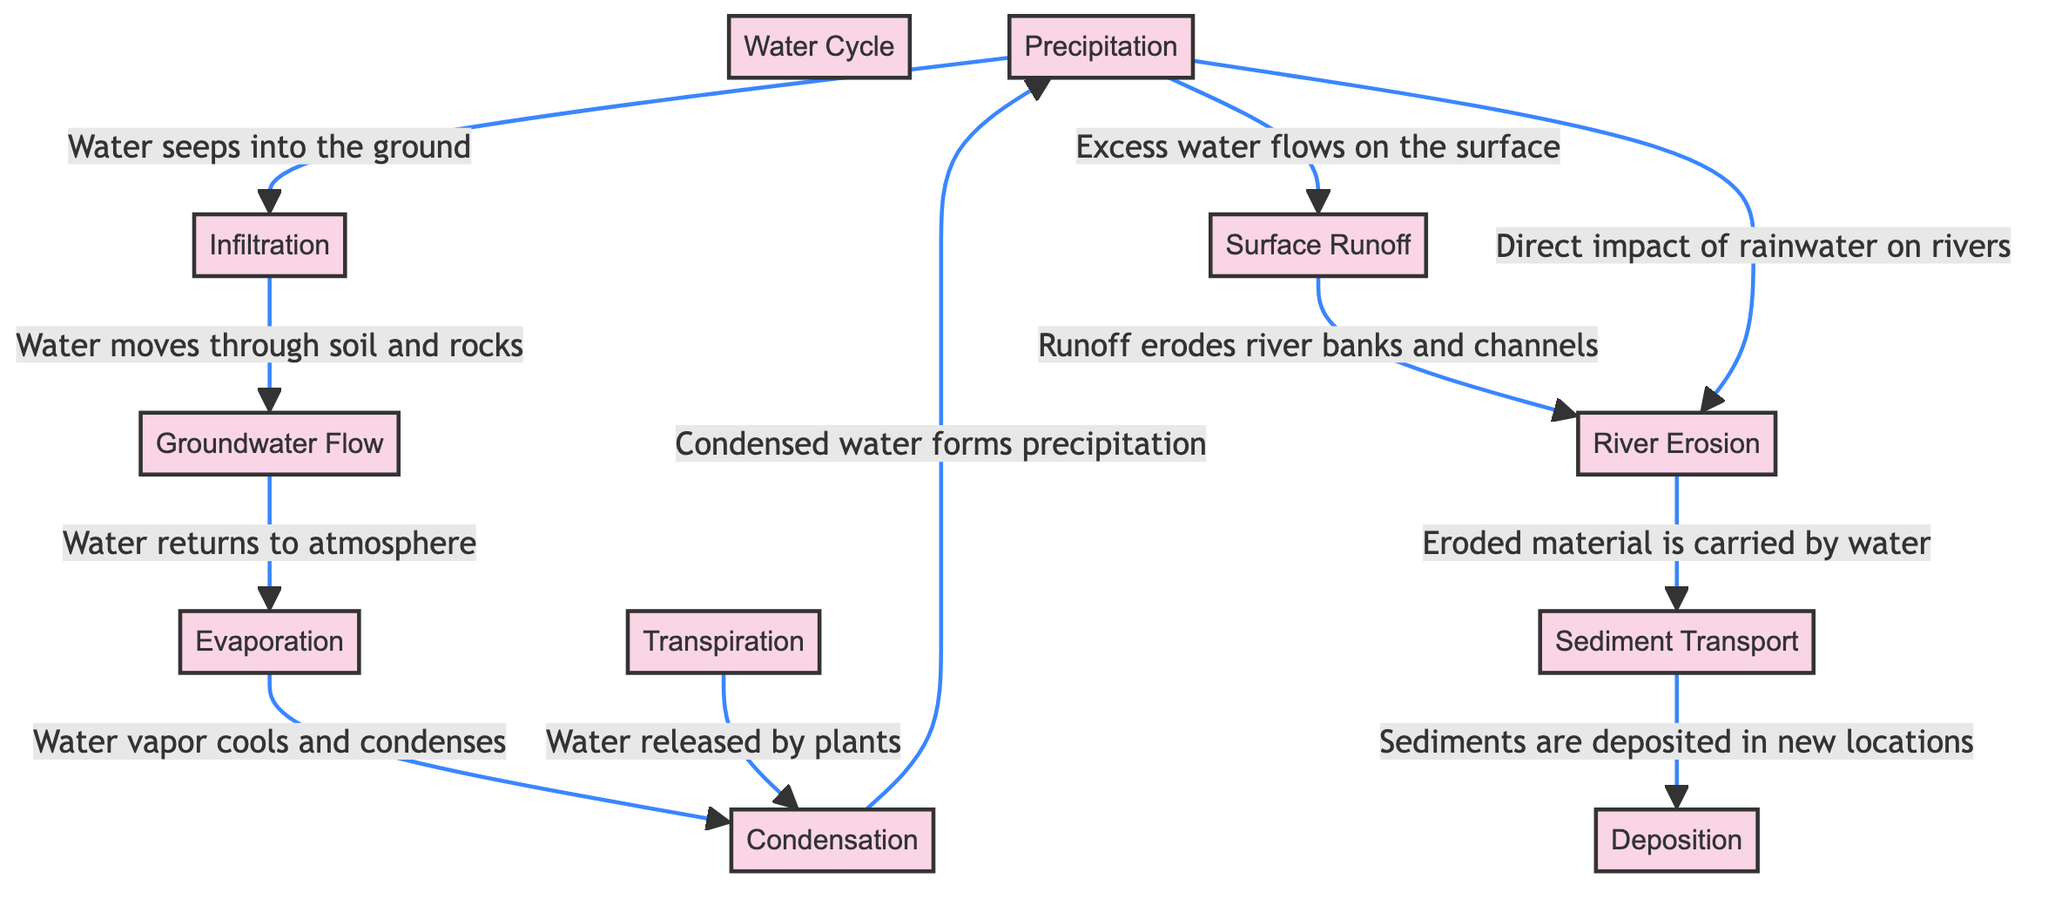What is the starting point of the diagram? The diagram begins with the node labeled "Water Cycle," which serves as the primary process connecting all other elements.
Answer: Water Cycle How many processes are shown in the diagram? There are 11 nodes labeled as processes, which include all the steps of the water cycle and its effects on geological structures.
Answer: 11 What process follows "Condensation"? The process that follows "Condensation" is "Precipitation," indicating that condensation leads to the formation of precipitation.
Answer: Precipitation Which process is directly impacted by "Precipitation"? "River Erosion" is directly impacted by "Precipitation," as indicated by a connection showing the direct influence of rainwater on rivers.
Answer: River Erosion What is the relationship between "Surface Runoff" and "River Erosion"? "Surface Runoff" leads to "River Erosion," as the runoff erodes river banks and channels.
Answer: Runoff erodes river banks and channels What happens to the eroded material from "River Erosion"? The eroded material from "River Erosion" is carried by water and enters the "Sediment Transport" process.
Answer: Carried by water How does "Groundwater Flow" contribute to the water cycle? "Groundwater Flow" moves water through soil and rocks, eventually returning to the atmosphere as "Evaporation."
Answer: Moves water through soil and rocks Which processes contribute to "Condensation"? Both "Transpiration" and "Evaporation" contribute to "Condensation" by releasing water into the atmosphere.
Answer: Transpiration and Evaporation What leads to the process of "Deposition"? The process of "Sediment Transport" leads to "Deposition," whereby sediments are deposited in new locations.
Answer: Sediment Transport 